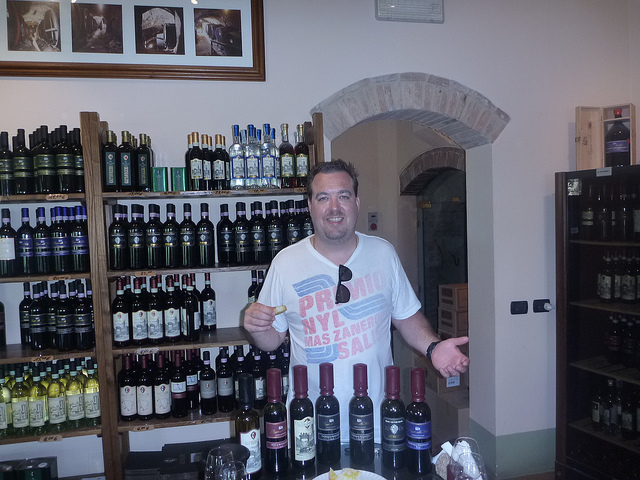What kind of store appears to be in the background? The image shows a man standing in front of shelves stocked with bottles of wine and olive oil, which suggests he is in a specialty shop that deals with gourmet foods or beverages. 